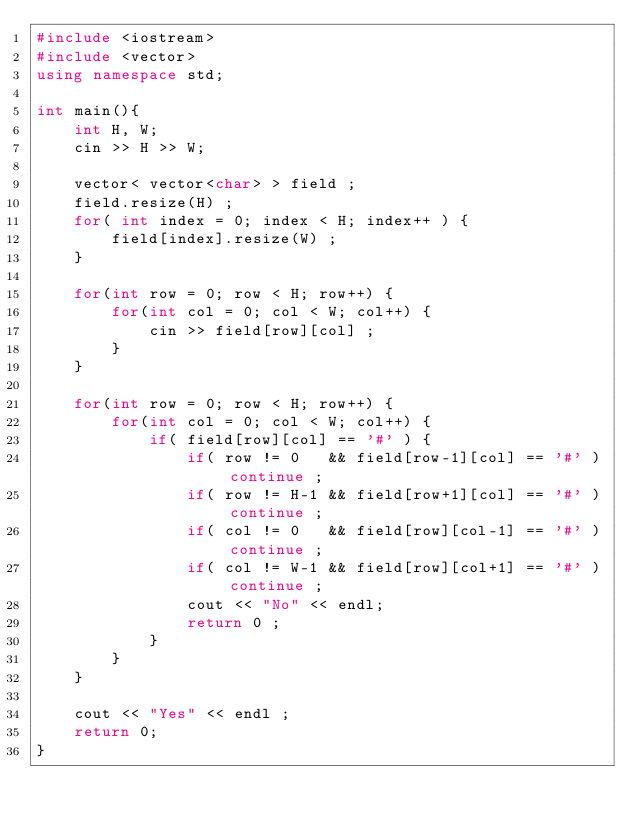Convert code to text. <code><loc_0><loc_0><loc_500><loc_500><_C++_>#include <iostream>
#include <vector>
using namespace std;
 
int main(){
    int H, W;
    cin >> H >> W;
    
    vector< vector<char> > field ;
    field.resize(H) ;
    for( int index = 0; index < H; index++ ) {
        field[index].resize(W) ;
    }

    for(int row = 0; row < H; row++) {
        for(int col = 0; col < W; col++) {
            cin >> field[row][col] ;
        }
    }

    for(int row = 0; row < H; row++) {
        for(int col = 0; col < W; col++) {
            if( field[row][col] == '#' ) {
                if( row != 0   && field[row-1][col] == '#' ) continue ;
                if( row != H-1 && field[row+1][col] == '#' ) continue ;
                if( col != 0   && field[row][col-1] == '#' ) continue ;
                if( col != W-1 && field[row][col+1] == '#' ) continue ;
                cout << "No" << endl;
                return 0 ;
            }
        }
    }

    cout << "Yes" << endl ; 
    return 0;
}
</code> 